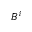<formula> <loc_0><loc_0><loc_500><loc_500>B ^ { i }</formula> 